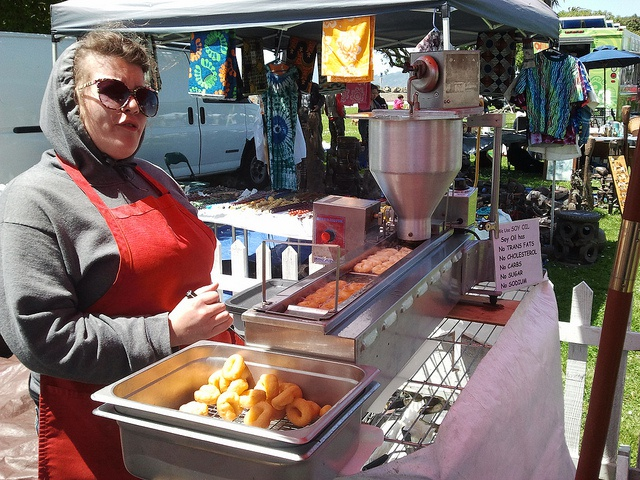Describe the objects in this image and their specific colors. I can see people in black, darkgray, maroon, and lightgray tones, truck in black, darkgray, and gray tones, umbrella in black, lightgray, gray, and darkgray tones, umbrella in black, blue, and lightgray tones, and umbrella in black and lightblue tones in this image. 